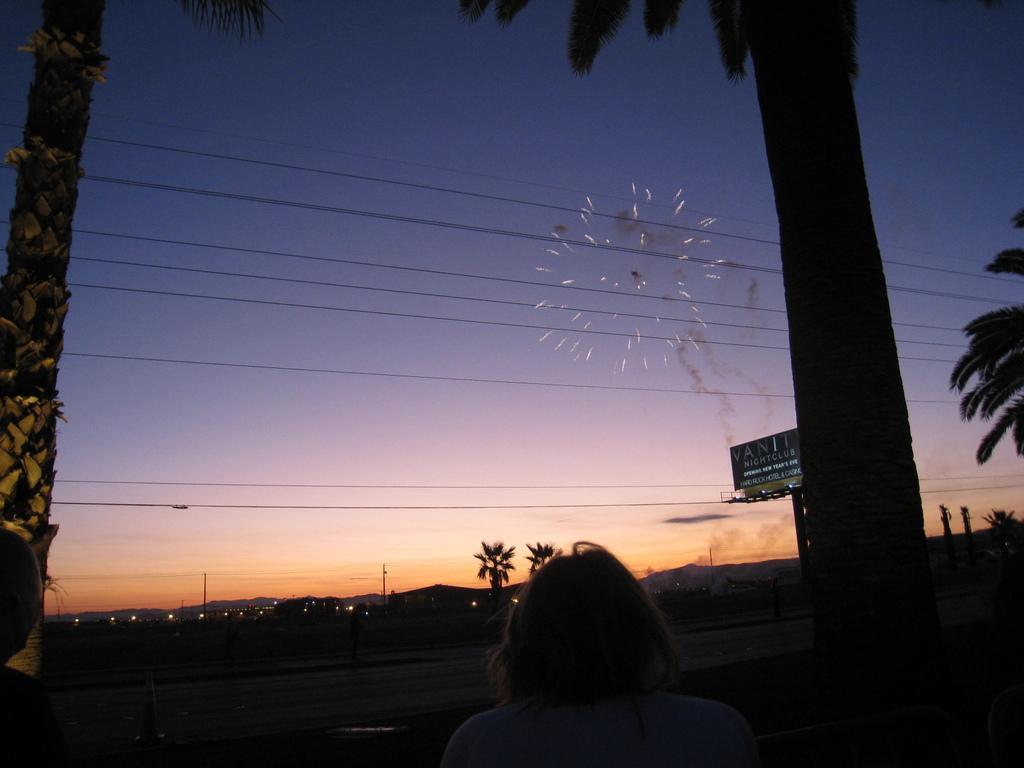Please provide a concise description of this image. In this picture we can see a girl standing in the front. Behind there are two coconut trees and some lights. On the top we can see the sunset sky and burning crackers. On the right corner we can see the tree trunk. 